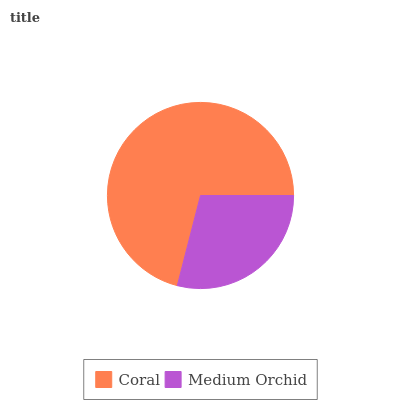Is Medium Orchid the minimum?
Answer yes or no. Yes. Is Coral the maximum?
Answer yes or no. Yes. Is Medium Orchid the maximum?
Answer yes or no. No. Is Coral greater than Medium Orchid?
Answer yes or no. Yes. Is Medium Orchid less than Coral?
Answer yes or no. Yes. Is Medium Orchid greater than Coral?
Answer yes or no. No. Is Coral less than Medium Orchid?
Answer yes or no. No. Is Coral the high median?
Answer yes or no. Yes. Is Medium Orchid the low median?
Answer yes or no. Yes. Is Medium Orchid the high median?
Answer yes or no. No. Is Coral the low median?
Answer yes or no. No. 